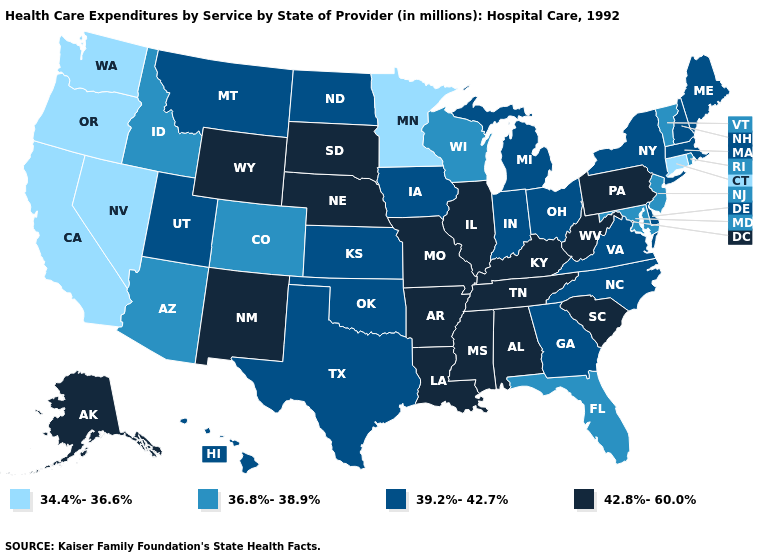Name the states that have a value in the range 42.8%-60.0%?
Be succinct. Alabama, Alaska, Arkansas, Illinois, Kentucky, Louisiana, Mississippi, Missouri, Nebraska, New Mexico, Pennsylvania, South Carolina, South Dakota, Tennessee, West Virginia, Wyoming. Does the first symbol in the legend represent the smallest category?
Be succinct. Yes. Among the states that border Connecticut , which have the highest value?
Answer briefly. Massachusetts, New York. Name the states that have a value in the range 39.2%-42.7%?
Short answer required. Delaware, Georgia, Hawaii, Indiana, Iowa, Kansas, Maine, Massachusetts, Michigan, Montana, New Hampshire, New York, North Carolina, North Dakota, Ohio, Oklahoma, Texas, Utah, Virginia. Name the states that have a value in the range 34.4%-36.6%?
Give a very brief answer. California, Connecticut, Minnesota, Nevada, Oregon, Washington. Name the states that have a value in the range 42.8%-60.0%?
Write a very short answer. Alabama, Alaska, Arkansas, Illinois, Kentucky, Louisiana, Mississippi, Missouri, Nebraska, New Mexico, Pennsylvania, South Carolina, South Dakota, Tennessee, West Virginia, Wyoming. Among the states that border Montana , does Idaho have the lowest value?
Concise answer only. Yes. Does Nebraska have a higher value than North Carolina?
Keep it brief. Yes. Does the map have missing data?
Concise answer only. No. What is the value of Connecticut?
Be succinct. 34.4%-36.6%. What is the lowest value in states that border South Dakota?
Give a very brief answer. 34.4%-36.6%. What is the lowest value in the USA?
Quick response, please. 34.4%-36.6%. What is the value of Virginia?
Short answer required. 39.2%-42.7%. Does New Mexico have the highest value in the USA?
Concise answer only. Yes. What is the lowest value in the South?
Short answer required. 36.8%-38.9%. 